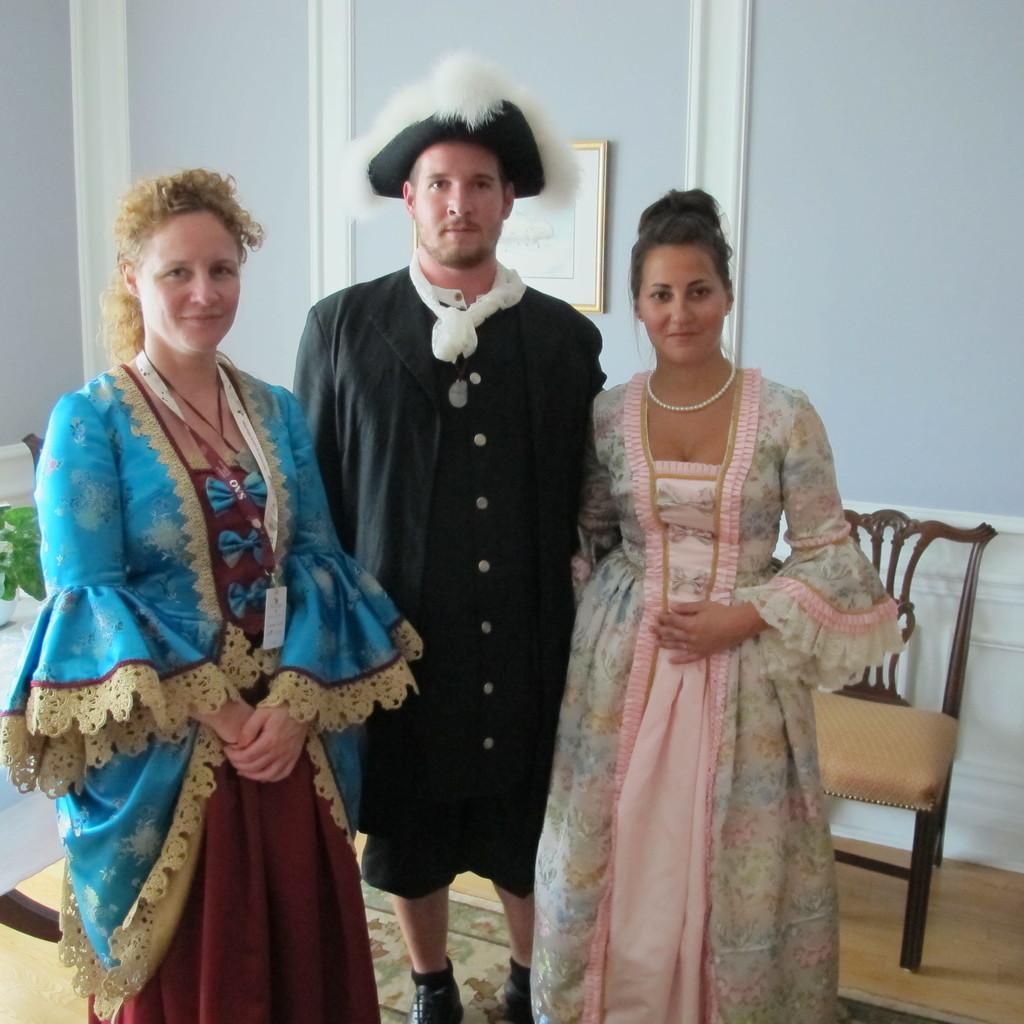Can you describe this image briefly? A picture is taken inside the room. In the image there are three people one man and two woman in background there is a wall which is in blue color and a photo frame. On right side there is a chair, and left side there is a plant with flower pot at bottom there is a pot. 